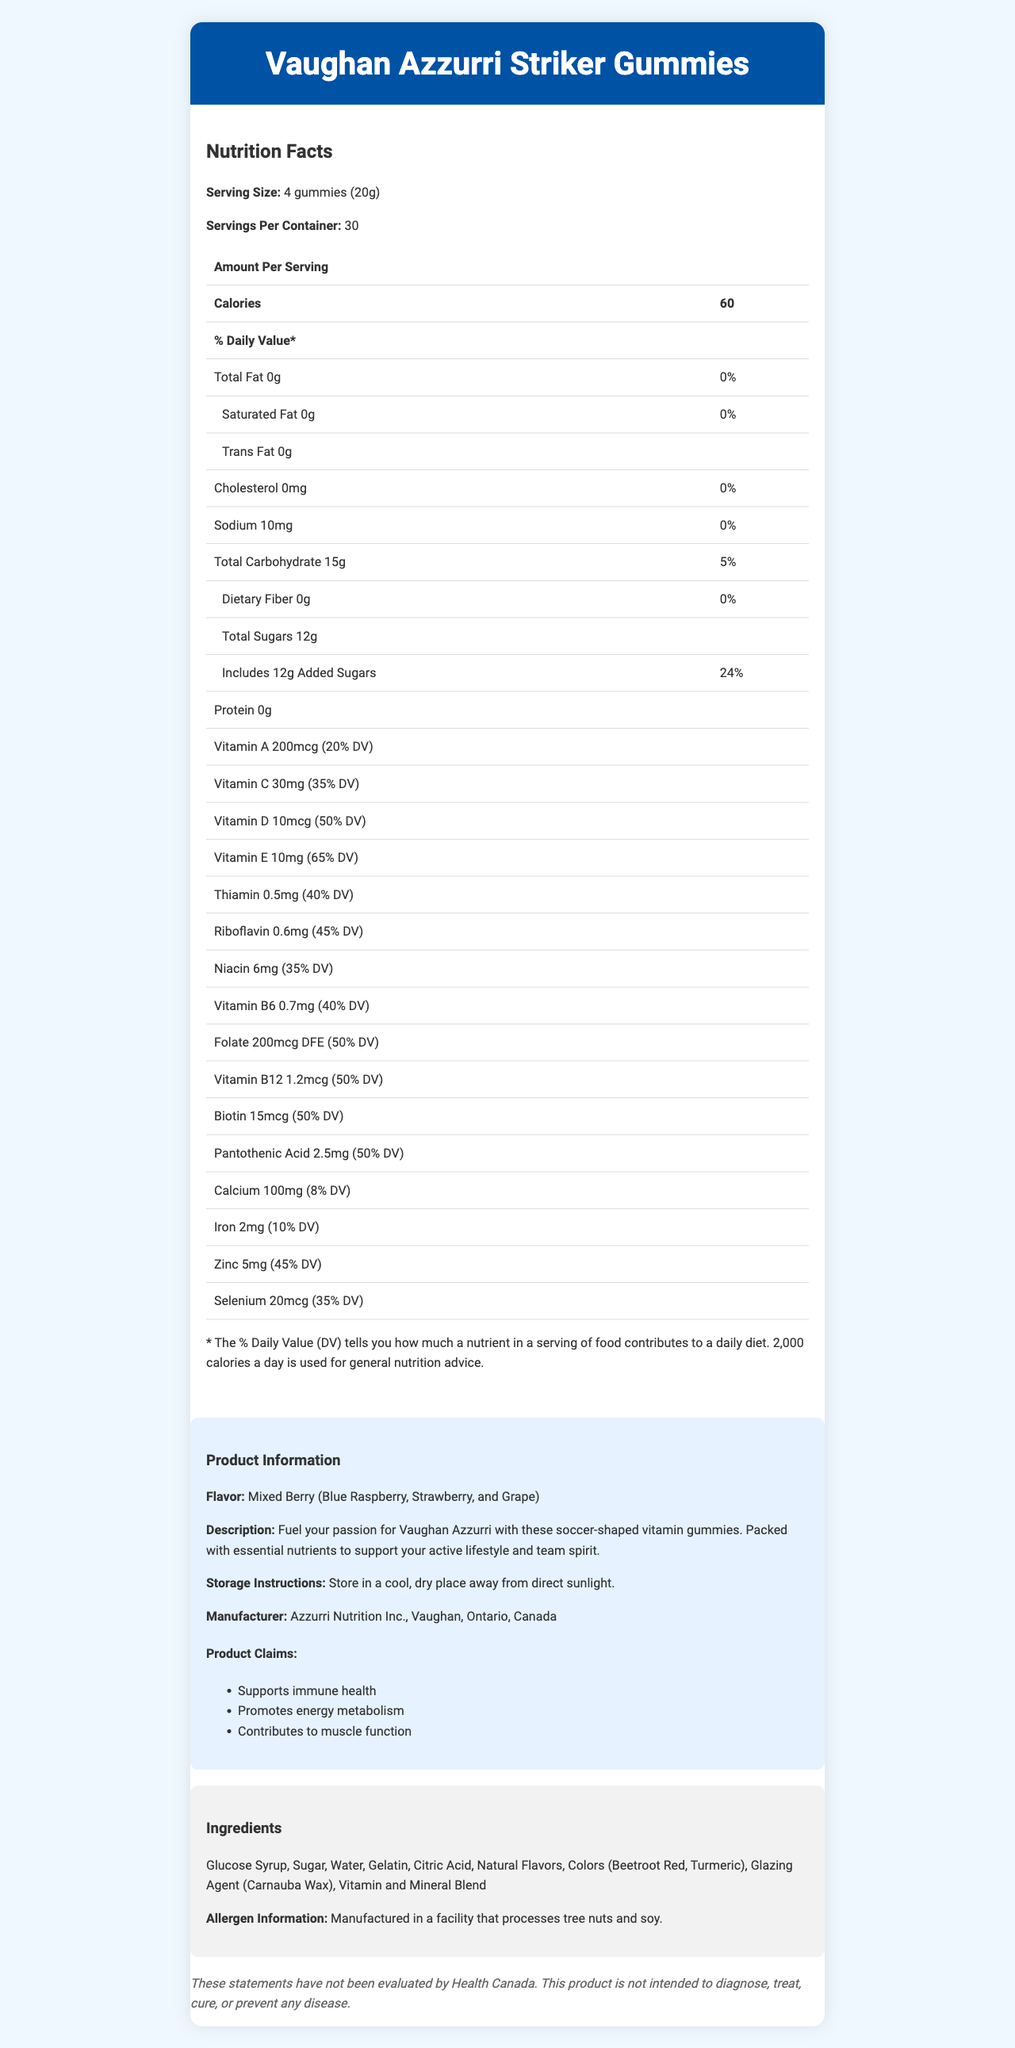what is the serving size of Vaughan Azzurri Striker Gummies? The serving size is explicitly mentioned in the Nutrition Facts section as "4 gummies (20g)".
Answer: 4 gummies (20g) how many servings are there in a container? The document states that there are 30 servings per container.
Answer: 30 how many calories are in one serving? The number of calories per serving is listed as 60 in the Nutrition Facts section.
Answer: 60 calories what is the total amount of sugars per serving? In the Nutrition Facts section, it states that the total sugars per serving amount to 12g.
Answer: 12g which vitamin has the highest % Daily Value? The document lists the % Daily Value for each vitamin, with Vitamin E having the highest at 65%.
Answer: Vitamin E (65% DV) what flavor are the gummies? The flavor is described in the Product Information section as "Mixed Berry (Blue Raspberry, Strawberry, and Grape)".
Answer: Mixed Berry (Blue Raspberry, Strawberry, and Grape) what are the allergens mentioned for these gummies? The Allergen Information section mentions that the product is manufactured in a facility that processes tree nuts and soy.
Answer: Tree nuts and soy what are the three main product claims mentioned? The Product Claims section lists these three claims.
Answer: Supports immune health, Promotes energy metabolism, Contributes to muscle function which mineral has the highest % Daily Value? The document lists Zinc with a 45% Daily Value, which is the highest among the minerals mentioned.
Answer: Zinc (45% DV) what should be the storage conditions for these gummies? The Storage Instructions provide this specific information.
Answer: Store in a cool, dry place away from direct sunlight. what is the total carbohydrate content per serving? A. 5g B. 10g C. 15g D. 20g The document states the total carbohydrate content per serving as 15g.
Answer: C how is the sodium content listed on the label? A. 0mg B. 10mg C. 20mg D. 30mg The sodium content is listed as 10mg in the Nutrition Facts section.
Answer: B are these gummies intended to diagnose, treat, cure, or prevent any disease? The disclaimer clearly states that this product is not intended to diagnose, treat, cure, or prevent any disease.
Answer: No summarize the main idea of this document. The summary covers all key sections: product description, nutritional content, health claims, storage instructions, and allergen information.
Answer: Vaughan Azzurri Striker Gummies are soccer-shaped vitamin-fortified gummy supplements with a mixed berry flavor. They provide essential nutrients to support immune health, energy metabolism, and muscle function. Each serving has 60 calories, 12g of sugars, and various vitamins and minerals. The product is manufactured in a facility that processes tree nuts and soy, and it should be stored in a cool, dry place away from direct sunlight. who is the target manufacturer for these gummies? While the document states "Azzurri Nutrition Inc., Vaughan, Ontario, Canada" as the manufacturer, it doesn't specify the target manufacturer in a different context.
Answer: Not enough information who is the head coach of Vaughan Azzurri? The document does not contain any information about the head coach of Vaughan Azzurri.
Answer: Not enough information 